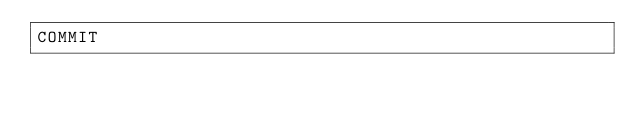<code> <loc_0><loc_0><loc_500><loc_500><_SQL_>COMMIT</code> 